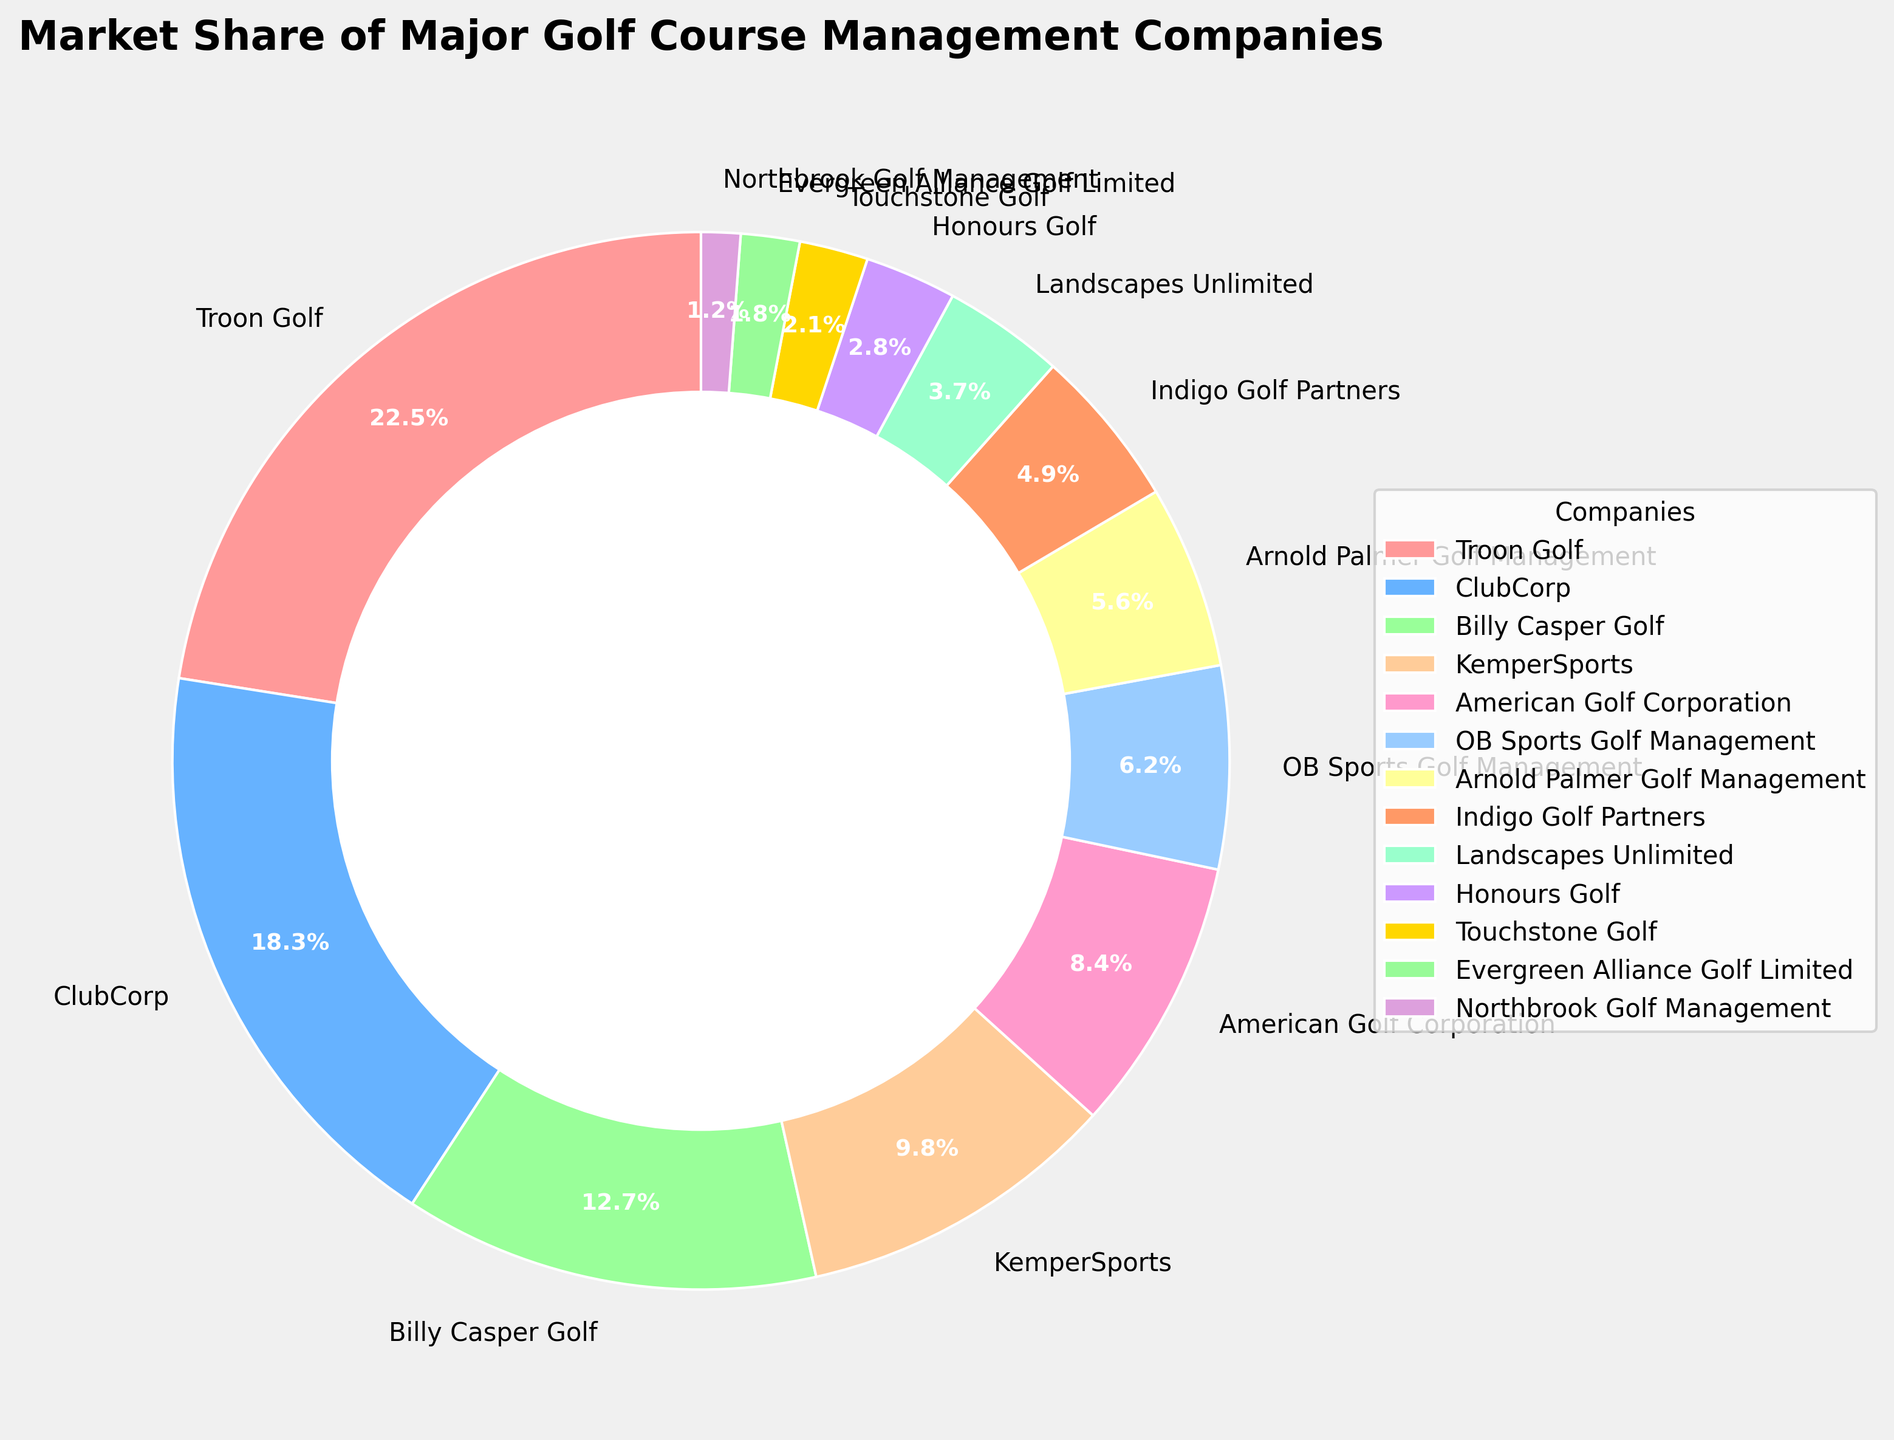Which company holds the largest market share in golf course management? By looking at the pie chart, the company with the largest segment is clearly identifiable.
Answer: Troon Golf What is the combined market share of the top three companies? Sum the market shares of Troon Golf (22.5%), ClubCorp (18.3%), and Billy Casper Golf (12.7%): 22.5 + 18.3 + 12.7 = 53.5%.
Answer: 53.5% How much larger is the market share of Troon Golf compared to American Golf Corporation? Subtract the market share of American Golf Corporation (8.4%) from Troon Golf (22.5%): 22.5 - 8.4 = 14.1%.
Answer: 14.1% Which company has the smallest market share and what is its percentage? The smallest segment in the pie chart corresponds to Northbrook Golf Management, with a market share of 1.2%.
Answer: Northbrook Golf Management with 1.2% Is the market share of KemperSports greater than or less than twice the market share of Indigo Golf Partners? Twice the market share of Indigo Golf Partners is 4.9% * 2 = 9.8%. KemperSports has a market share of 9.8%, which is equal to twice that of Indigo Golf Partners.
Answer: Equal to How many companies have a market share greater than 10%? By examining the pie chart, Troon Golf, ClubCorp, and Billy Casper Golf all have market shares exceeding 10%.
Answer: 3 What is the average market share of OB Sports Golf Management and Arnold Palmer Golf Management? Add the market shares of OB Sports Golf Management (6.2%) and Arnold Palmer Golf Management (5.6%) then divide by 2: (6.2 + 5.6) / 2 = 5.9%.
Answer: 5.9% What is the difference in market share between the company with the largest share and the company with the smallest share? Subtract the smallest market share (1.2% by Northbrook Golf Management) from the largest market share (22.5% by Troon Golf): 22.5 - 1.2 = 21.3%.
Answer: 21.3% Is the market share of ClubCorp greater than the combined market share of Honours Golf and Touchstone Golf? The combined market share of Honours Golf (2.8%) and Touchstone Golf (2.1%) is 4.9%. ClubCorp has a market share of 18.3%, which is greater than 4.9%.
Answer: Yes 